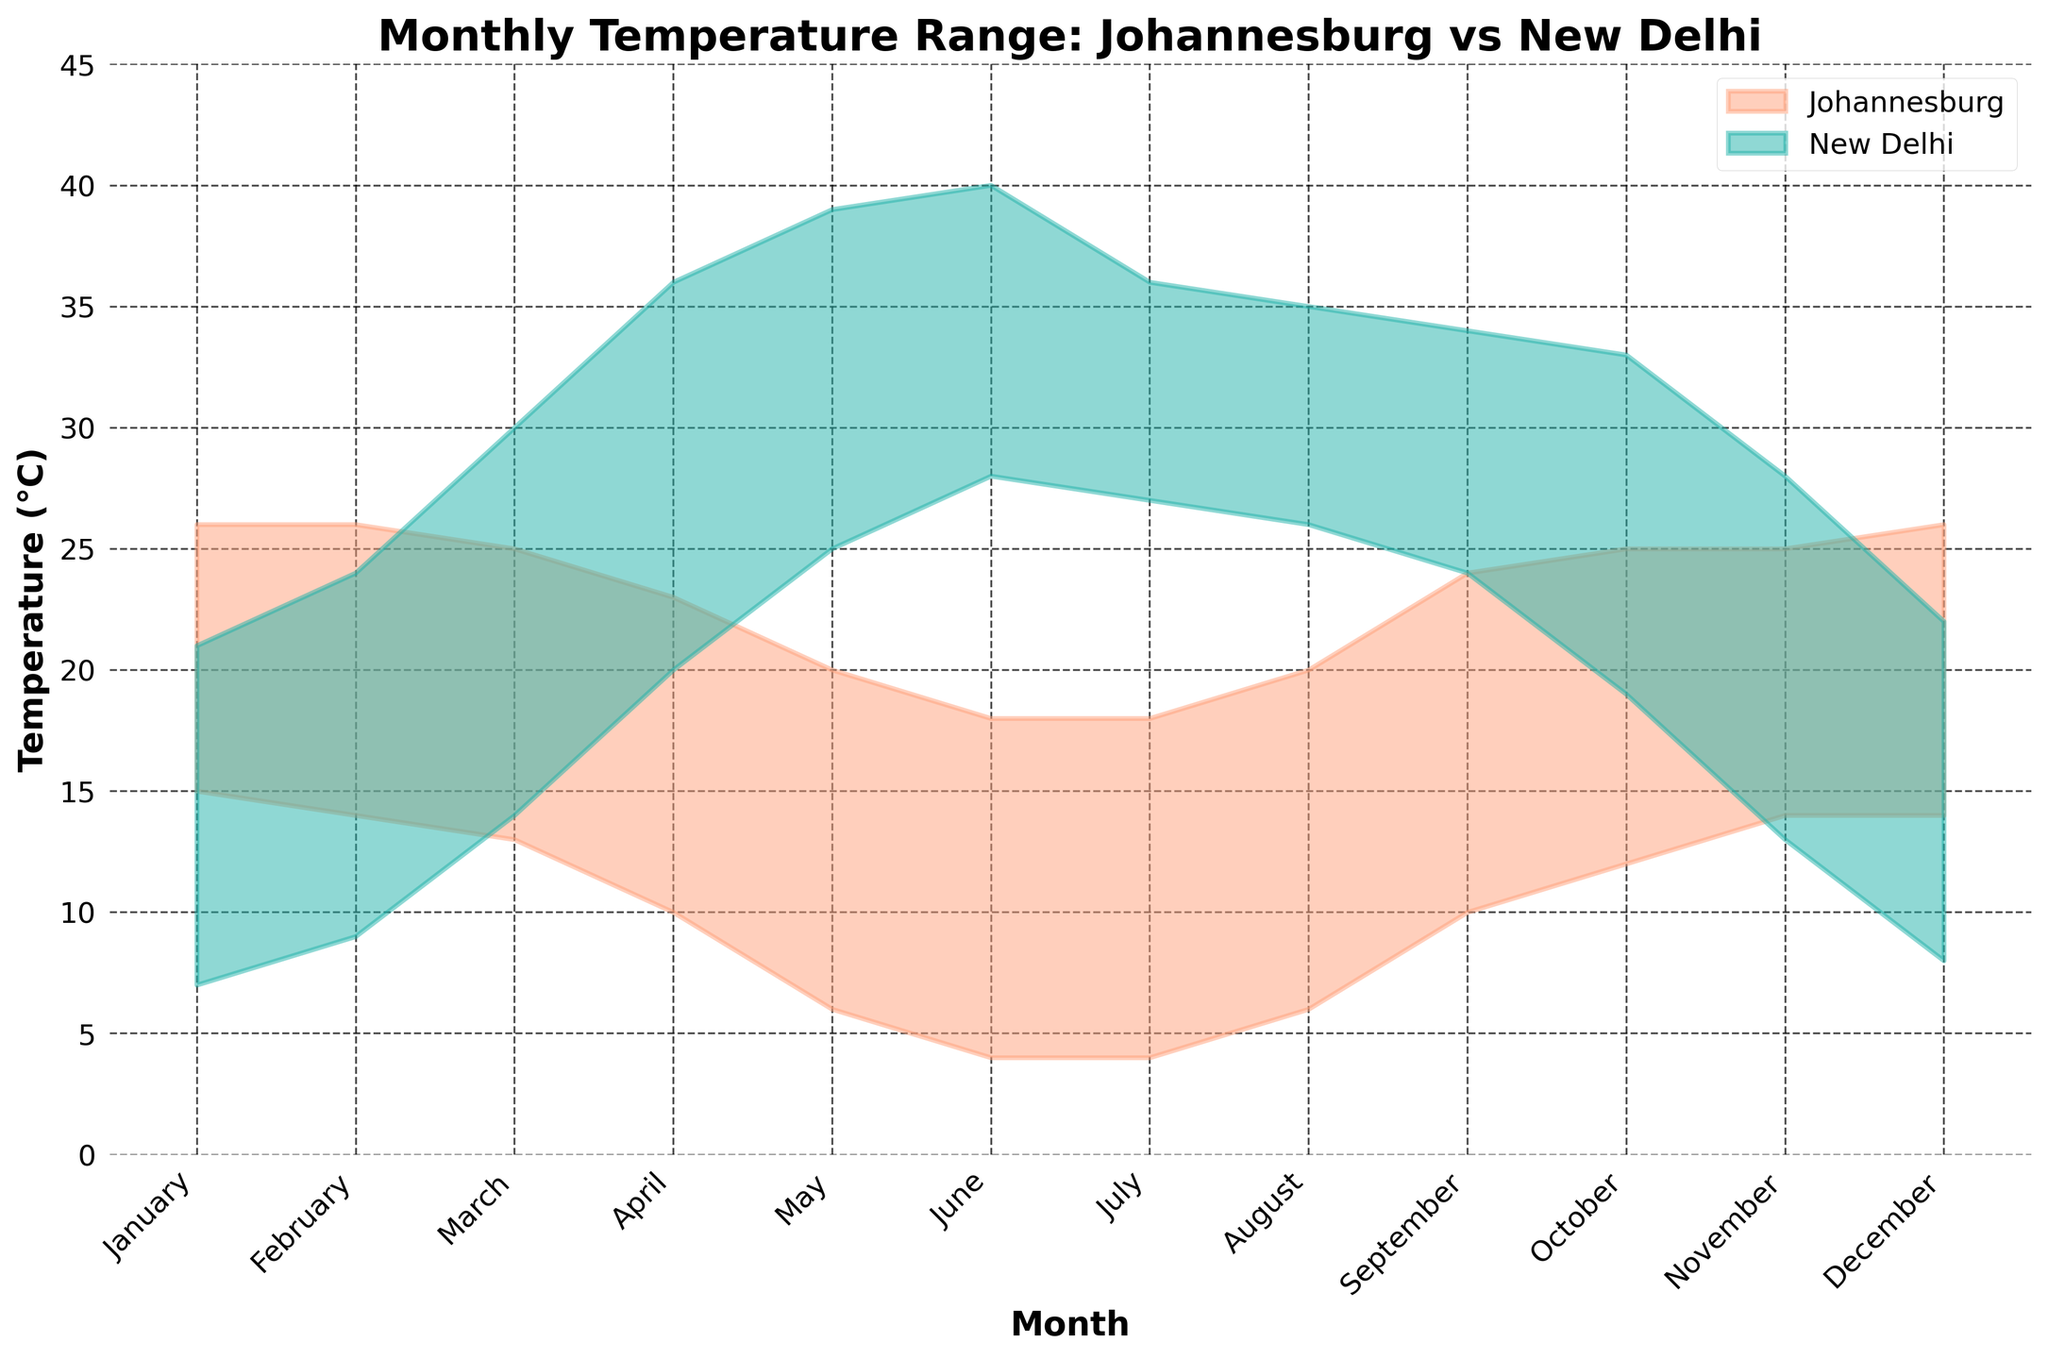What is the title of the figure? The title is typically placed at the top of the figure and is there to help viewers understand the subject of the chart.
Answer: Monthly Temperature Range: Johannesburg vs New Delhi Which city has a higher temperature range in June? Look at the filled areas for June on the x-axis: Johannesburg's range is from 4°C to 18°C, while New Delhi's range is from 28°C to 40°C. Compare these ranges to see which is wider.
Answer: New Delhi What are the temperature ranges of Johannesburg and New Delhi in December? Identify December on the x-axis and read the corresponding y-values for both Johannesburg and New Delhi's shaded areas.
Answer: Johannesburg: 14°C to 26°C; New Delhi: 8°C to 22°C In which month does Johannesburg have its lowest high temperature? Look at the top boundary of the Johannesburg shaded area across all months and identify the lowest value.
Answer: June and July (18°C) During which month does New Delhi have its highest high temperature? Identify the highest boundary of the New Delhi shaded area and find the corresponding month on the x-axis.
Answer: June (40°C) Which city has more consistent temperature ranges throughout the year? Analyze the width of the shaded areas over all months for both cities. Johannesburg's range width is more consistent, while New Delhi's varies greatly.
Answer: Johannesburg What is the difference between the high temperatures of Johannesburg and New Delhi in April? Find the high temperatures for April for both Johannesburg (23°C) and New Delhi (36°C), then subtract the Johannesburg value from the New Delhi value.
Answer: 13°C How do the temperature ranges of Johannesburg and New Delhi compare in January? Identify the temperature ranges for both cities in January on the x-axis. Compare Johannesburg's range (15°C to 26°C) and New Delhi's range (7°C to 21°C).
Answer: Johannesburg's range is higher What is the average high temperature in New Delhi over the year? Add up the high temperatures for each month in New Delhi (21+24+30+36+39+40+36+35+34+33+28+22) and divide by 12 to find the average.
Answer: 31.25°C 